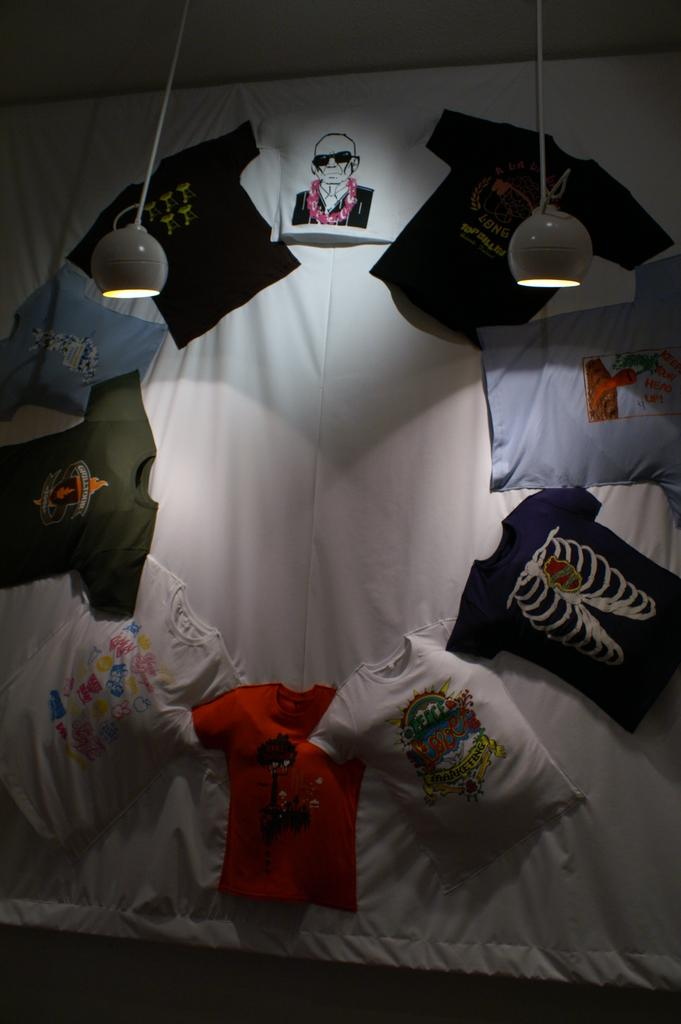What is the main object in the center of the image? There is a blanket in the center of the image. What is placed on the blanket? There are t-shirts on the blanket. What can be seen at the top of the image? There are two lights at the top of the image. What is visible in the background of the image? There is a wall in the background of the image. What type of powder is being used to clean the t-shirts in the image? There is no powder or cleaning activity depicted in the image; it only shows a blanket with t-shirts on it. What type of vest is being worn by the person in the image? There is no person or vest present in the image. 